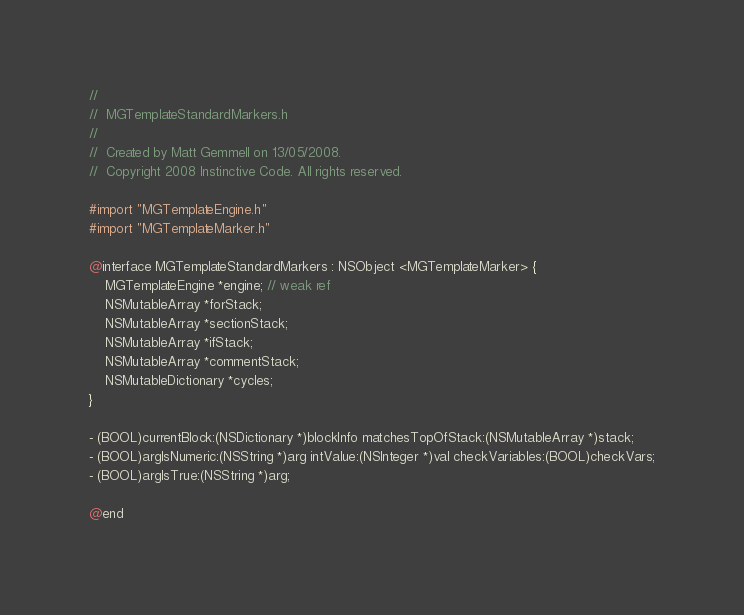Convert code to text. <code><loc_0><loc_0><loc_500><loc_500><_C_>//
//  MGTemplateStandardMarkers.h
//
//  Created by Matt Gemmell on 13/05/2008.
//  Copyright 2008 Instinctive Code. All rights reserved.

#import "MGTemplateEngine.h"
#import "MGTemplateMarker.h"

@interface MGTemplateStandardMarkers : NSObject <MGTemplateMarker> {
	MGTemplateEngine *engine; // weak ref
	NSMutableArray *forStack;
	NSMutableArray *sectionStack;
	NSMutableArray *ifStack;
	NSMutableArray *commentStack;
	NSMutableDictionary *cycles;
}

- (BOOL)currentBlock:(NSDictionary *)blockInfo matchesTopOfStack:(NSMutableArray *)stack;
- (BOOL)argIsNumeric:(NSString *)arg intValue:(NSInteger *)val checkVariables:(BOOL)checkVars;
- (BOOL)argIsTrue:(NSString *)arg;

@end
</code> 